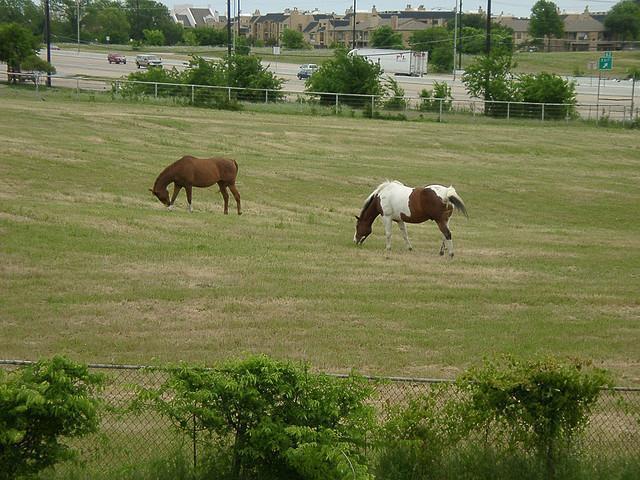How many horses are there?
Give a very brief answer. 2. How many people are sitting down?
Give a very brief answer. 0. 